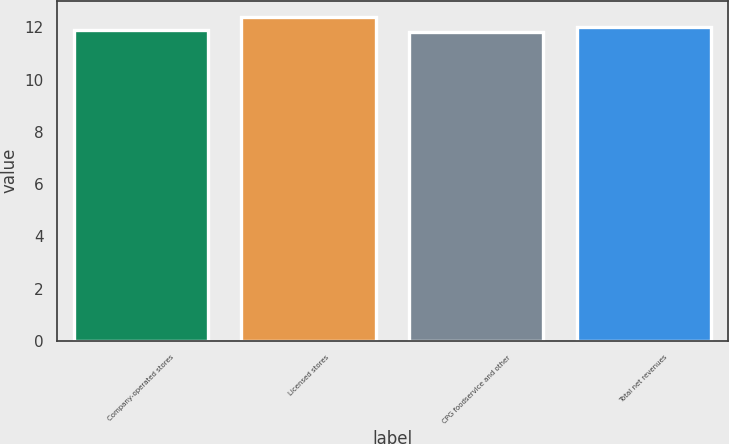Convert chart. <chart><loc_0><loc_0><loc_500><loc_500><bar_chart><fcel>Company-operated stores<fcel>Licensed stores<fcel>CPG foodservice and other<fcel>Total net revenues<nl><fcel>11.9<fcel>12.4<fcel>11.8<fcel>12<nl></chart> 